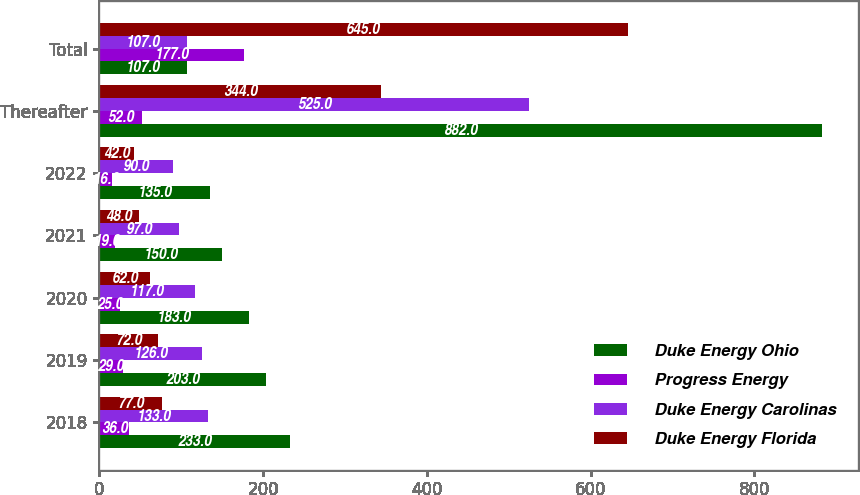Convert chart to OTSL. <chart><loc_0><loc_0><loc_500><loc_500><stacked_bar_chart><ecel><fcel>2018<fcel>2019<fcel>2020<fcel>2021<fcel>2022<fcel>Thereafter<fcel>Total<nl><fcel>Duke Energy Ohio<fcel>233<fcel>203<fcel>183<fcel>150<fcel>135<fcel>882<fcel>107<nl><fcel>Progress Energy<fcel>36<fcel>29<fcel>25<fcel>19<fcel>16<fcel>52<fcel>177<nl><fcel>Duke Energy Carolinas<fcel>133<fcel>126<fcel>117<fcel>97<fcel>90<fcel>525<fcel>107<nl><fcel>Duke Energy Florida<fcel>77<fcel>72<fcel>62<fcel>48<fcel>42<fcel>344<fcel>645<nl></chart> 